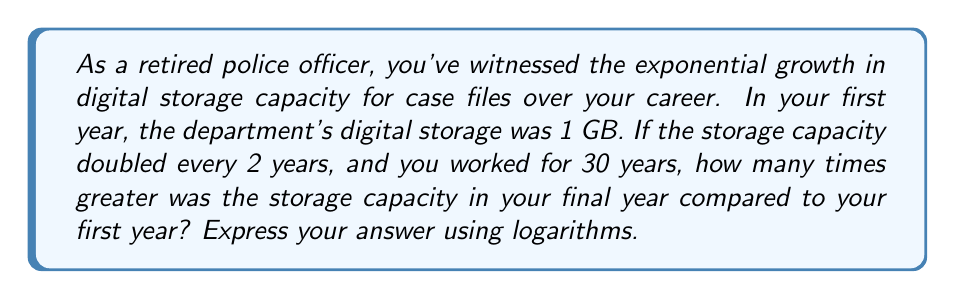Teach me how to tackle this problem. Let's approach this step-by-step:

1) First, we need to determine how many times the storage doubled over 30 years:
   Number of doublings = 30 years ÷ 2 years per doubling = 15 doublings

2) Now, we can express the final storage capacity in terms of the initial capacity:
   Final capacity = Initial capacity × $2^{15}$

3) To find how many times greater the final capacity is compared to the initial:
   $\frac{\text{Final capacity}}{\text{Initial capacity}} = \frac{\text{Initial capacity} × 2^{15}}{\text{Initial capacity}} = 2^{15}$

4) To express this using logarithms, we can use the property that:
   If $y = 2^x$, then $\log_2(y) = x$

5) In this case, we want to find $x$ where $2^x = 2^{15}$

6) Taking the logarithm (base 2) of both sides:
   $\log_2(2^x) = \log_2(2^{15})$

7) Using the logarithm property $\log_a(a^x) = x$:
   $x = 15$

Therefore, the storage capacity in the final year was $2^{15}$ times greater, which can be expressed as $\log_2(\text{increase factor}) = 15$.
Answer: $\log_2(\text{increase factor}) = 15$ 